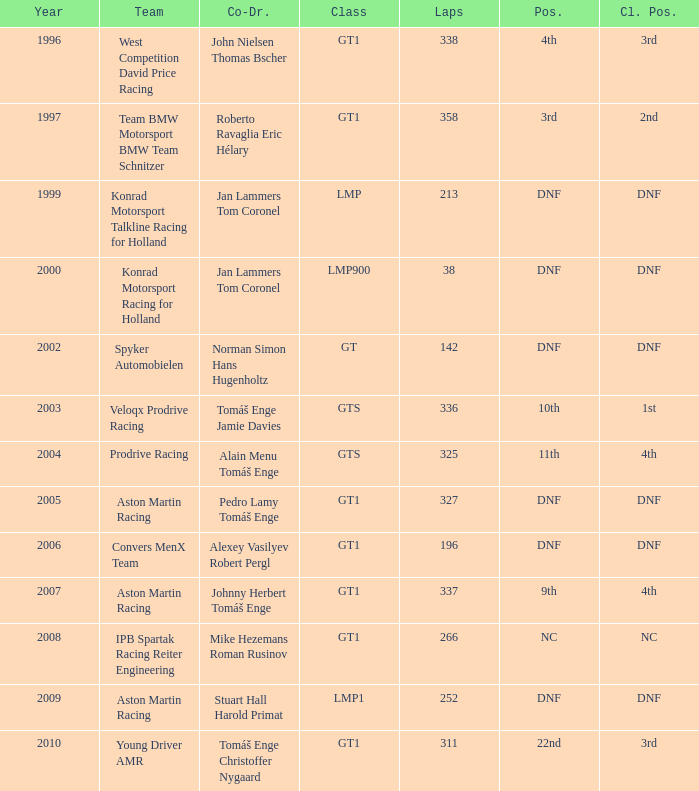What was the position in 1997? 3rd. 